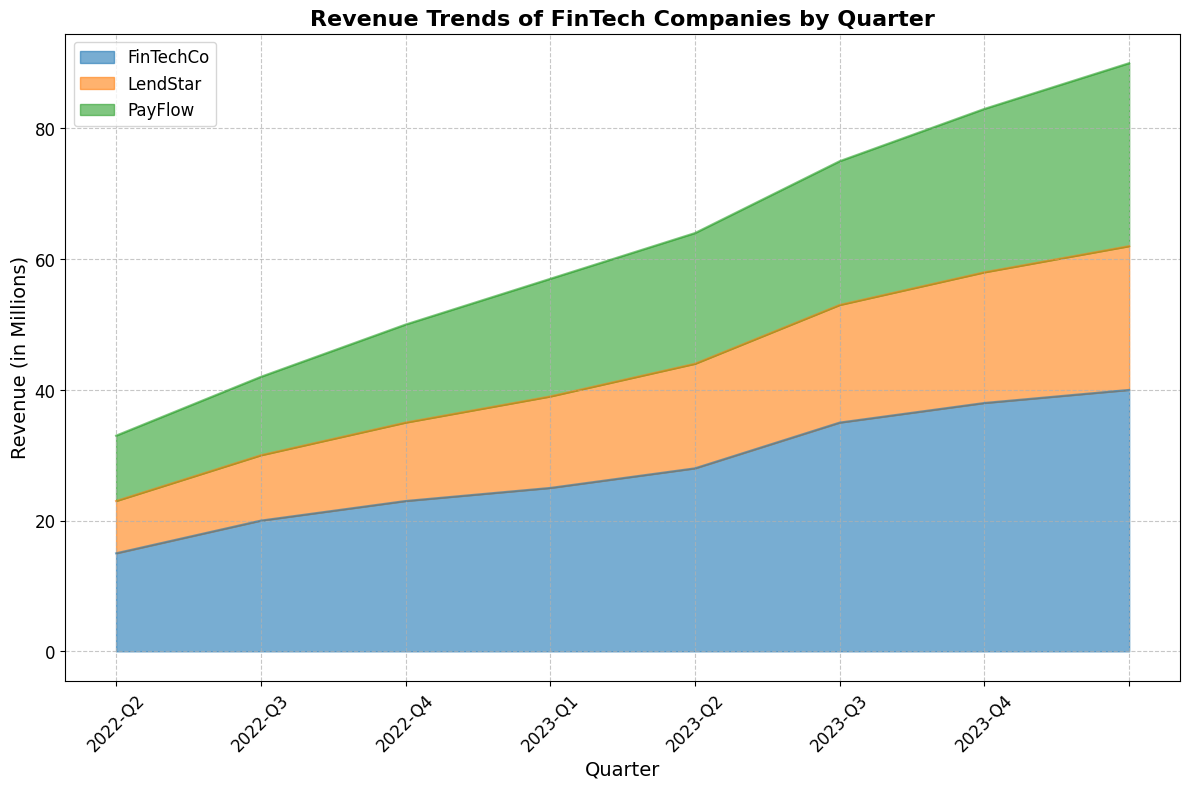What's the total revenue for FinTechCo in 2023? To find the total revenue for FinTechCo in 2023, we sum up the revenue for each quarter of 2023: 28 (Q1) + 35 (Q2) + 38 (Q3) + 40 (Q4) = 141
Answer: 141 Which company had the highest revenue in 2022-Q4? To determine which company had the highest revenue in 2022-Q4, we compare the revenues: FinTechCo had 25, PayFlow had 18, and LendStar had 14. FinTechCo had the highest revenue.
Answer: FinTechCo What is the revenue growth for PayFlow from 2022-Q1 to 2023-Q4? Revenue growth is calculated as the difference between the revenue in 2023-Q4 and 2022-Q1. For PayFlow: 28 (2023-Q4) - 10 (2022-Q1) = 18
Answer: 18 Which company showed the most consistent revenue growth from 2022-Q1 to 2023-Q4? Consistent revenue growth means having steady increases over each quarter. By examining the trends, we see that FinTechCo grew from 15 to 40, PayFlow from 10 to 28, and LendStar from 8 to 22. Each increment for LendStar's quarters is equal and smaller compared to the others. Therefore, LendStar had the most consistent growth.
Answer: LendStar In which quarter did FinTechCo experience the largest increase in revenue compared to the previous quarter? We calculate the quarter-to-quarter increase for FinTechCo: 
Q2 = 20 - 15 = 5,
Q3 = 23 - 20 = 3,
Q4 = 25 - 23 = 2,
Q1 (2023) = 28 - 25 = 3,
Q2 (2023) = 35 - 28 = 7,
Q3 (2023) = 38 - 35 = 3,
Q4 (2023) = 40 - 38 = 2.
The largest increase is from 2023-Q1 to 2023-Q2 with an increase of 7.
Answer: 2023-Q2 Which company had the smallest growth in revenue from 2022-Q1 to 2022-Q2? We compare the growth for each company:
FinTechCo: 20 - 15 = 5,
PayFlow: 12 - 10 = 2,
LendStar: 10 - 8 = 2.
Both PayFlow and LendStar had the smallest growth with an increase of 2.
Answer: PayFlow and LendStar How does FinTechCo's revenue in 2023-Q4 compare to PayFlow's revenue in the same quarter? FinTechCo's revenue in 2023-Q4 was 40, while PayFlow's revenue was 28. FinTechCo's revenue is greater.
Answer: FinTechCo's revenue is greater What is the average revenue for LendStar in 2022? To find the average revenue, we sum the revenues for LendStar in 2022 and divide by the number of quarters: (8 + 10 + 12 + 14) / 4 = 44 / 4 = 11
Answer: 11 Between which consecutive quarters did PayFlow have the smallest revenue increase? We calculate the revenue increase between each consecutive quarter for PayFlow:
Q2 = 12 - 10 = 2,
Q3 = 15 - 12 = 3,
Q4 = 18 - 15 = 3,
Q1 (2023) = 20 - 18 = 2,
Q2 (2023) = 22 - 20 = 2,
Q3 (2023) = 25 - 22 = 3,
Q4 (2023) = 28 - 25 = 3.
The smallest increases are from 2022-Q1 to 2022-Q2, 2023-Q1 to 2023-Q2, and 2022-Q2 to 2023-Q1, all with an increase of 2.
Answer: 2022-Q1 to 2022-Q2, 2023-Q1 to 2023-Q2, 2022-Q2 to 2023-Q1 What is the combined revenue of all three companies in 2023-Q3? To find the combined revenue, we sum the revenues of all three companies for 2023-Q3: FinTechCo (38) + PayFlow (25) + LendStar (20) = 83
Answer: 83 